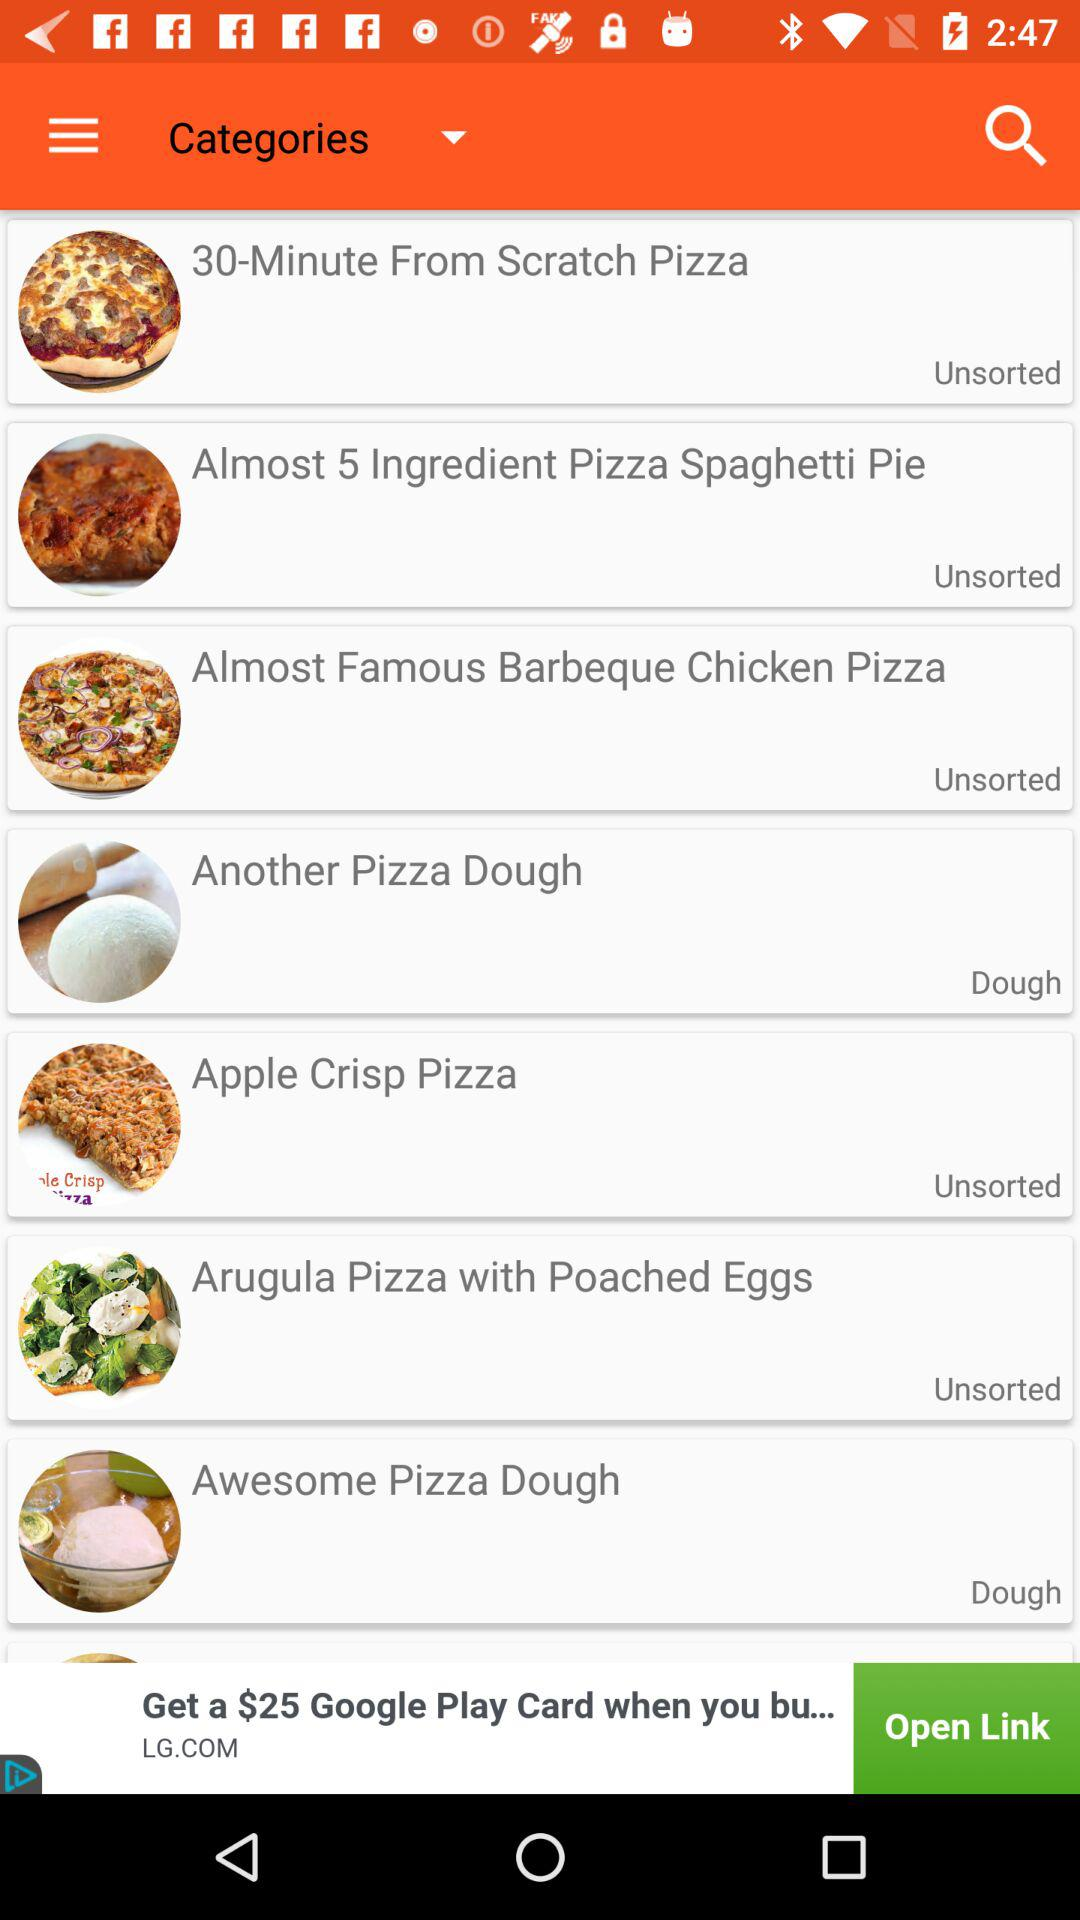Which category does "Apple Crisp Pizza" belong to? "Apple Crisp Pizza" belongs to the "Unsorted" category. 